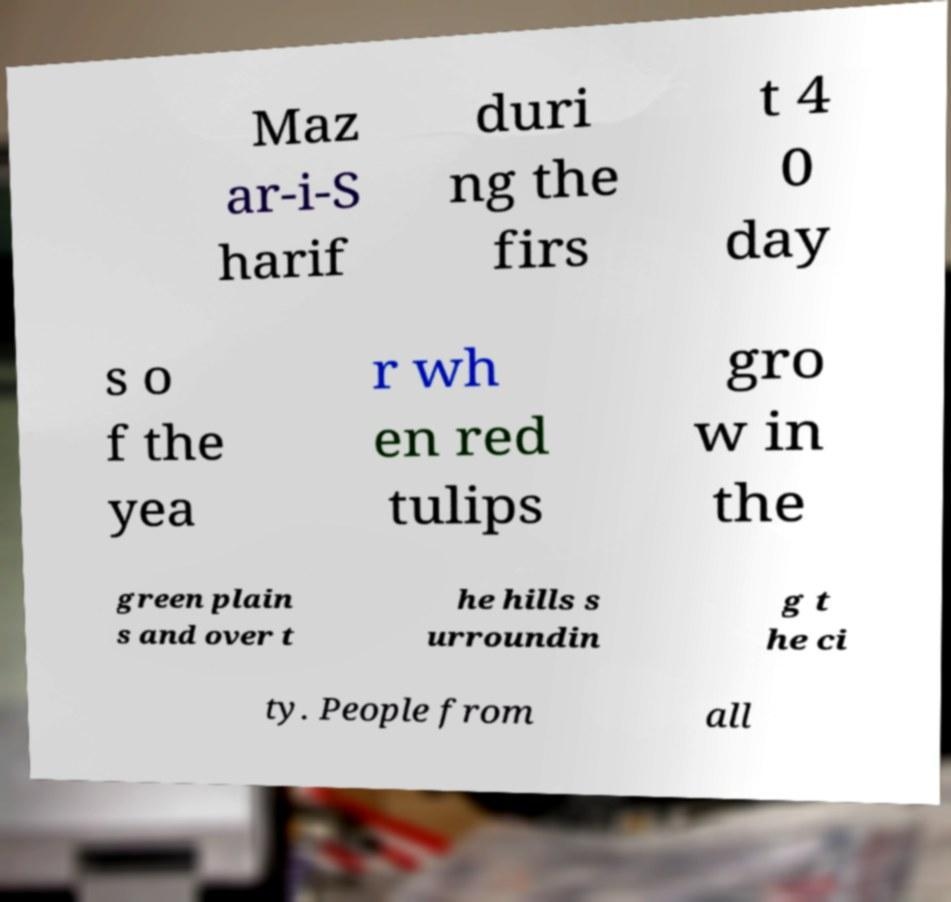Please read and relay the text visible in this image. What does it say? Maz ar-i-S harif duri ng the firs t 4 0 day s o f the yea r wh en red tulips gro w in the green plain s and over t he hills s urroundin g t he ci ty. People from all 